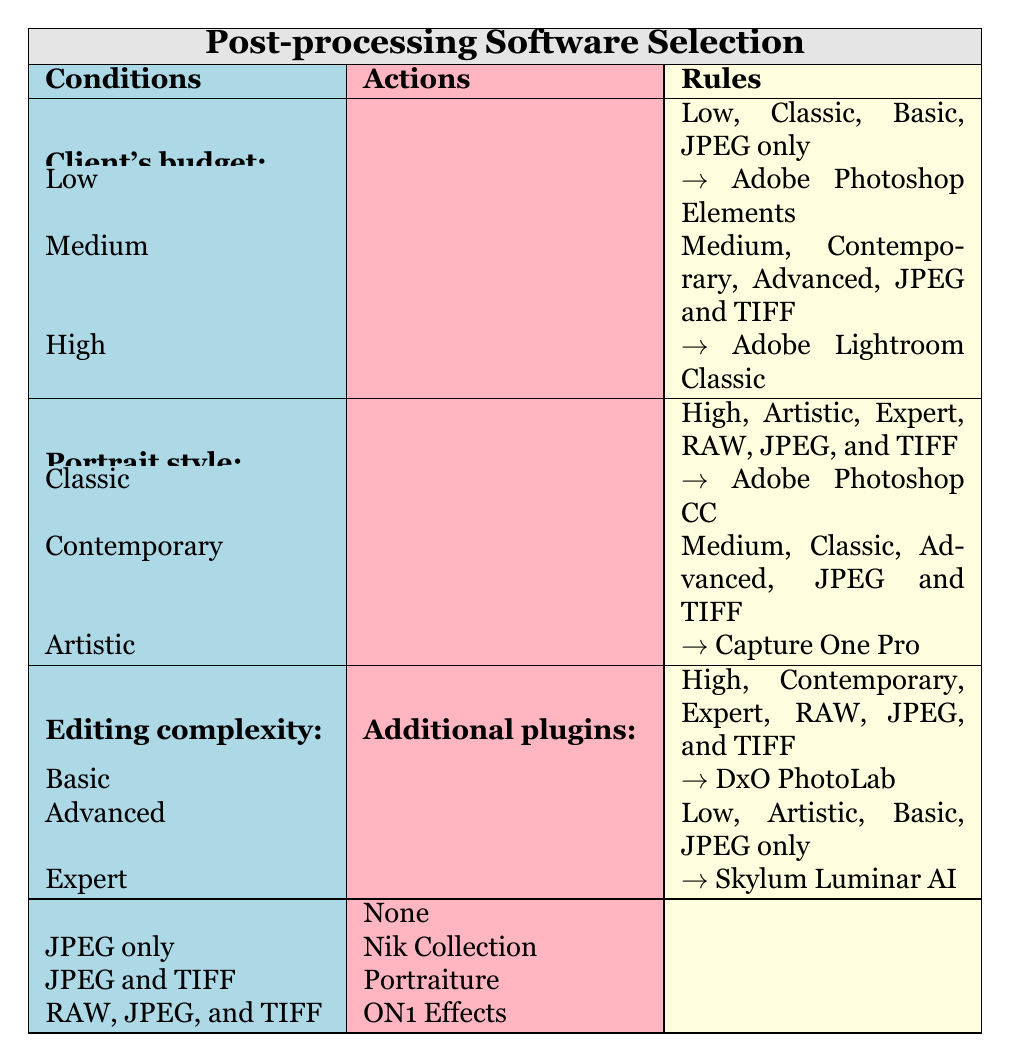What recommended software should a client with a low budget, classic portrait style, basic editing complexity, and JPEG only output format use? The condition combines the attributes of a low budget, classic style and basic complexity requiring a JPEG only format. Referring to the table, the corresponding recommendation is Adobe Photoshop Elements.
Answer: Adobe Photoshop Elements If a client has a medium budget and requires advanced editing with JPEG and TIFF formats, what additional plugins do they need? According to the table, a medium budget along with advanced editing for JPEG and TIFF output matches the action of recommending Adobe Lightroom Classic and requires the Nik Collection as an additional plugin.
Answer: Nik Collection Is DxO PhotoLab recommended for high-budget artistic portraits with expert editing complexity and RAW, JPEG, and TIFF formats? The conditions show that for high-budget artistic portraits with expert complexity and the requirement for RAW, JPEG, and TIFF formats, DxO PhotoLab is not listed as a recommendation. The correct recommendation in this scenario is Adobe Photoshop CC.
Answer: No What is the recommended software for a low budget, artistic portrait style, and basic editing complexity with JPEG only output? The conditions specify a low budget, artistic portrait style, and basic editing with JPEG only output. Referring to the table, the option given is Skylum Luminar AI.
Answer: Skylum Luminar AI How many total different software options are listed in the table? The table lists six unique software options: Adobe Photoshop Elements, Capture One Pro, Adobe Lightroom Classic, DxO PhotoLab, Skylum Luminar AI, and Adobe Photoshop CC, totaling six different software options.
Answer: 6 If a client prefers contemporary style and high budget with expert editing and requires RAW, JPEG, and TIFF formats, what are the recommended software and additional plugins? Analyzing the conditions of contemporary style, high budget, expert editing, and RAW, JPEG, and TIFF formats, the table indicates that DxO PhotoLab is recommended along with the Nik Collection as an additional plugin. Hence, interpreting the combined recommendations fits this scenario.
Answer: DxO PhotoLab, Nik Collection Does the table suggest that basic editing for classic portraits with JPEG and TIFF formats involves any additional plugins? The conditions for classic portraits regarding basic editing and JPEG and TIFF formats do not require any additional plugins as indicated in the table entry.
Answer: No How many software options are recommended for advanced editing complexity? To find the answer, examine the rules: Adobe Lightroom Classic, Capture One Pro, DxO PhotoLab, and Adobe Photoshop CC are suitable for advanced editing complexity, totaling four software options.
Answer: 4 